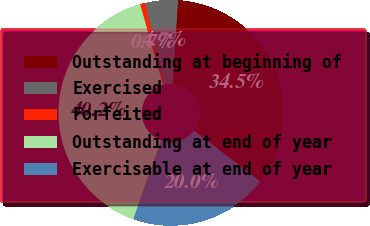Convert chart to OTSL. <chart><loc_0><loc_0><loc_500><loc_500><pie_chart><fcel>Outstanding at beginning of<fcel>Exercised<fcel>Forfeited<fcel>Outstanding at end of year<fcel>Exercisable at end of year<nl><fcel>34.46%<fcel>4.67%<fcel>0.72%<fcel>40.17%<fcel>19.98%<nl></chart> 